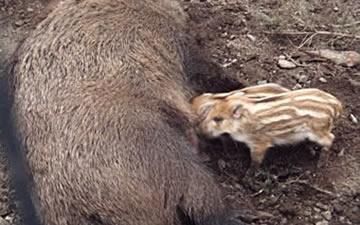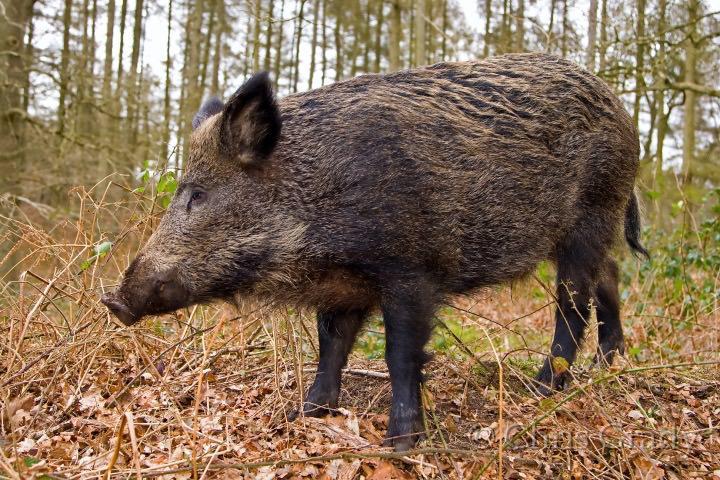The first image is the image on the left, the second image is the image on the right. Assess this claim about the two images: "An image includes at least three striped baby pigs next to a standing adult wild hog.". Correct or not? Answer yes or no. No. The first image is the image on the left, the second image is the image on the right. For the images shown, is this caption "The left image contains at least four boars." true? Answer yes or no. No. 